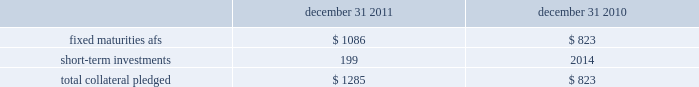The hartford financial services group , inc .
Notes to consolidated financial statements ( continued ) 5 .
Investments and derivative instruments ( continued ) collateral arrangements the company enters into various collateral arrangements in connection with its derivative instruments , which require both the pledging and accepting of collateral .
As of december 31 , 2011 and 2010 , collateral pledged having a fair value of $ 1.1 billion and $ 790 , respectively , was included in fixed maturities , afs , in the consolidated balance sheets .
From time to time , the company enters into secured borrowing arrangements as a means to increase net investment income .
The company received cash collateral of $ 33 as of december 31 , 2011 and 2010 .
The table presents the classification and carrying amount of loaned securities and derivative instruments collateral pledged. .
As of december 31 , 2011 and 2010 , the company had accepted collateral with a fair value of $ 2.6 billion and $ 1.5 billion , respectively , of which $ 2.0 billion and $ 1.1 billion , respectively , was cash collateral which was invested and recorded in the consolidated balance sheets in fixed maturities and short-term investments with corresponding amounts recorded in other assets and other liabilities .
The company is only permitted by contract to sell or repledge the noncash collateral in the event of a default by the counterparty .
As of december 31 , 2011 and 2010 , noncash collateral accepted was held in separate custodial accounts and was not included in the company 2019s consolidated balance sheets .
Securities on deposit with states the company is required by law to deposit securities with government agencies in states where it conducts business .
As of december 31 , 2011 and 2010 , the fair value of securities on deposit was approximately $ 1.6 billion and $ 1.4 billion , respectively. .
What is the change in value of fixed maturities afs from 2010 to 2011 , ( in billions ) ? 
Computations: (1086 - 823)
Answer: 263.0. The hartford financial services group , inc .
Notes to consolidated financial statements ( continued ) 5 .
Investments and derivative instruments ( continued ) collateral arrangements the company enters into various collateral arrangements in connection with its derivative instruments , which require both the pledging and accepting of collateral .
As of december 31 , 2011 and 2010 , collateral pledged having a fair value of $ 1.1 billion and $ 790 , respectively , was included in fixed maturities , afs , in the consolidated balance sheets .
From time to time , the company enters into secured borrowing arrangements as a means to increase net investment income .
The company received cash collateral of $ 33 as of december 31 , 2011 and 2010 .
The table presents the classification and carrying amount of loaned securities and derivative instruments collateral pledged. .
As of december 31 , 2011 and 2010 , the company had accepted collateral with a fair value of $ 2.6 billion and $ 1.5 billion , respectively , of which $ 2.0 billion and $ 1.1 billion , respectively , was cash collateral which was invested and recorded in the consolidated balance sheets in fixed maturities and short-term investments with corresponding amounts recorded in other assets and other liabilities .
The company is only permitted by contract to sell or repledge the noncash collateral in the event of a default by the counterparty .
As of december 31 , 2011 and 2010 , noncash collateral accepted was held in separate custodial accounts and was not included in the company 2019s consolidated balance sheets .
Securities on deposit with states the company is required by law to deposit securities with government agencies in states where it conducts business .
As of december 31 , 2011 and 2010 , the fair value of securities on deposit was approximately $ 1.6 billion and $ 1.4 billion , respectively. .
What was the ratio of the collateral pledged in 2011 to 2010? 
Computations: (1.1 / 790)
Answer: 0.00139. 